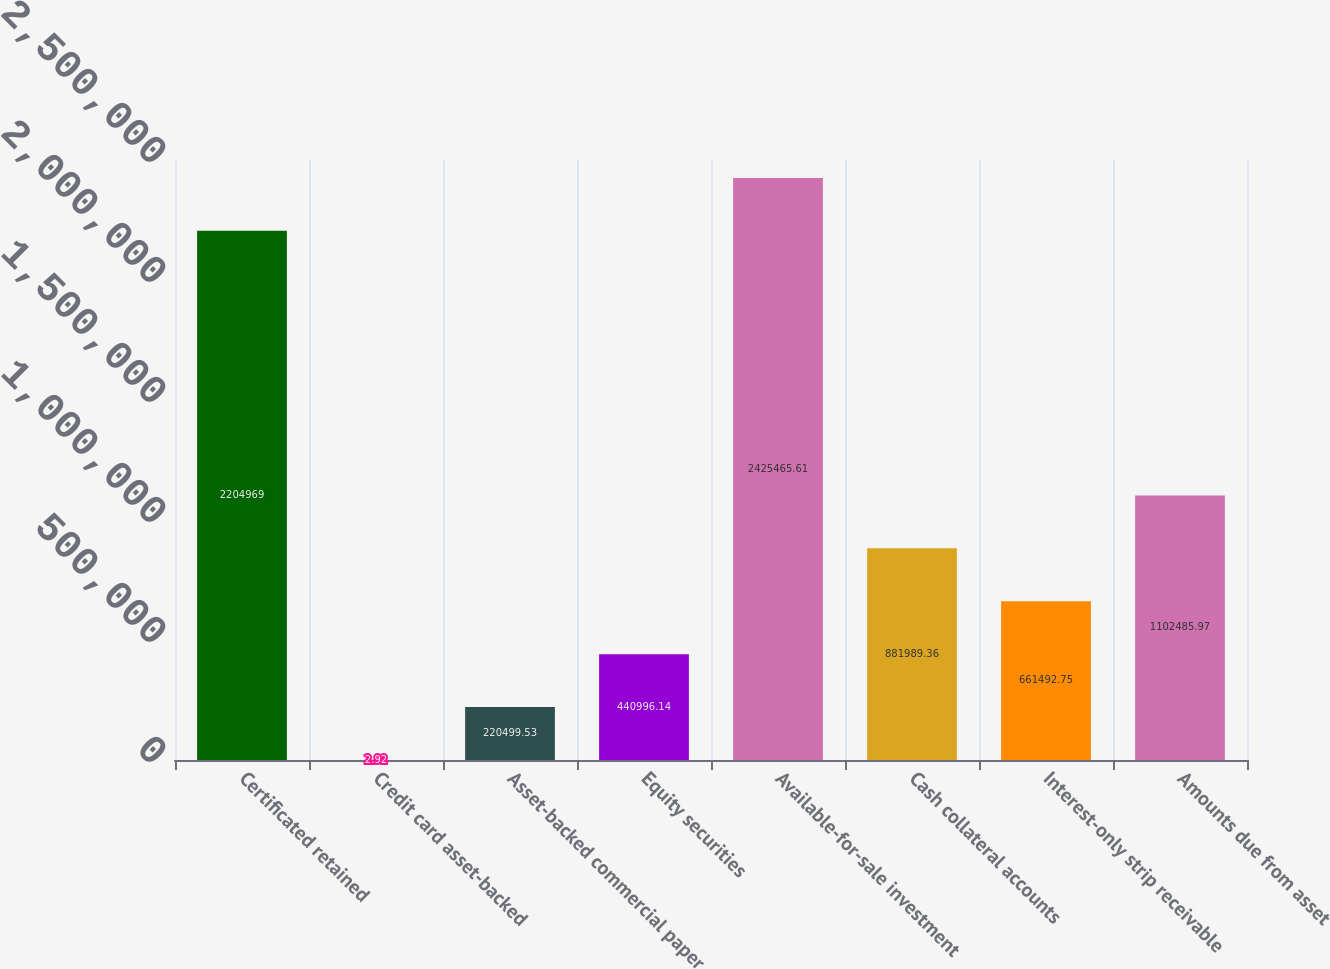Convert chart. <chart><loc_0><loc_0><loc_500><loc_500><bar_chart><fcel>Certificated retained<fcel>Credit card asset-backed<fcel>Asset-backed commercial paper<fcel>Equity securities<fcel>Available-for-sale investment<fcel>Cash collateral accounts<fcel>Interest-only strip receivable<fcel>Amounts due from asset<nl><fcel>2.20497e+06<fcel>2.92<fcel>220500<fcel>440996<fcel>2.42547e+06<fcel>881989<fcel>661493<fcel>1.10249e+06<nl></chart> 